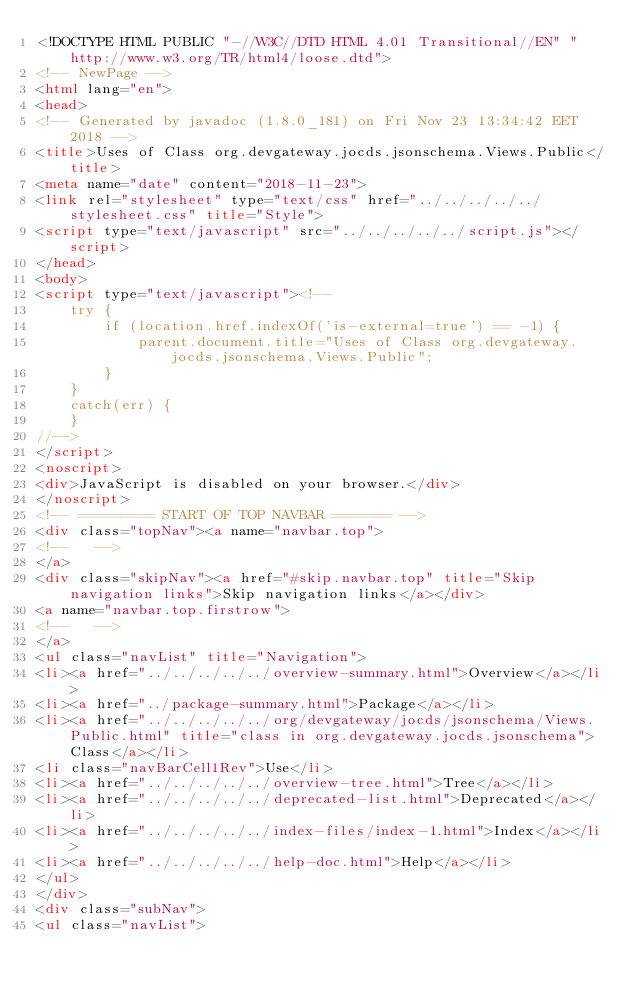<code> <loc_0><loc_0><loc_500><loc_500><_HTML_><!DOCTYPE HTML PUBLIC "-//W3C//DTD HTML 4.01 Transitional//EN" "http://www.w3.org/TR/html4/loose.dtd">
<!-- NewPage -->
<html lang="en">
<head>
<!-- Generated by javadoc (1.8.0_181) on Fri Nov 23 13:34:42 EET 2018 -->
<title>Uses of Class org.devgateway.jocds.jsonschema.Views.Public</title>
<meta name="date" content="2018-11-23">
<link rel="stylesheet" type="text/css" href="../../../../../stylesheet.css" title="Style">
<script type="text/javascript" src="../../../../../script.js"></script>
</head>
<body>
<script type="text/javascript"><!--
    try {
        if (location.href.indexOf('is-external=true') == -1) {
            parent.document.title="Uses of Class org.devgateway.jocds.jsonschema.Views.Public";
        }
    }
    catch(err) {
    }
//-->
</script>
<noscript>
<div>JavaScript is disabled on your browser.</div>
</noscript>
<!-- ========= START OF TOP NAVBAR ======= -->
<div class="topNav"><a name="navbar.top">
<!--   -->
</a>
<div class="skipNav"><a href="#skip.navbar.top" title="Skip navigation links">Skip navigation links</a></div>
<a name="navbar.top.firstrow">
<!--   -->
</a>
<ul class="navList" title="Navigation">
<li><a href="../../../../../overview-summary.html">Overview</a></li>
<li><a href="../package-summary.html">Package</a></li>
<li><a href="../../../../../org/devgateway/jocds/jsonschema/Views.Public.html" title="class in org.devgateway.jocds.jsonschema">Class</a></li>
<li class="navBarCell1Rev">Use</li>
<li><a href="../../../../../overview-tree.html">Tree</a></li>
<li><a href="../../../../../deprecated-list.html">Deprecated</a></li>
<li><a href="../../../../../index-files/index-1.html">Index</a></li>
<li><a href="../../../../../help-doc.html">Help</a></li>
</ul>
</div>
<div class="subNav">
<ul class="navList"></code> 